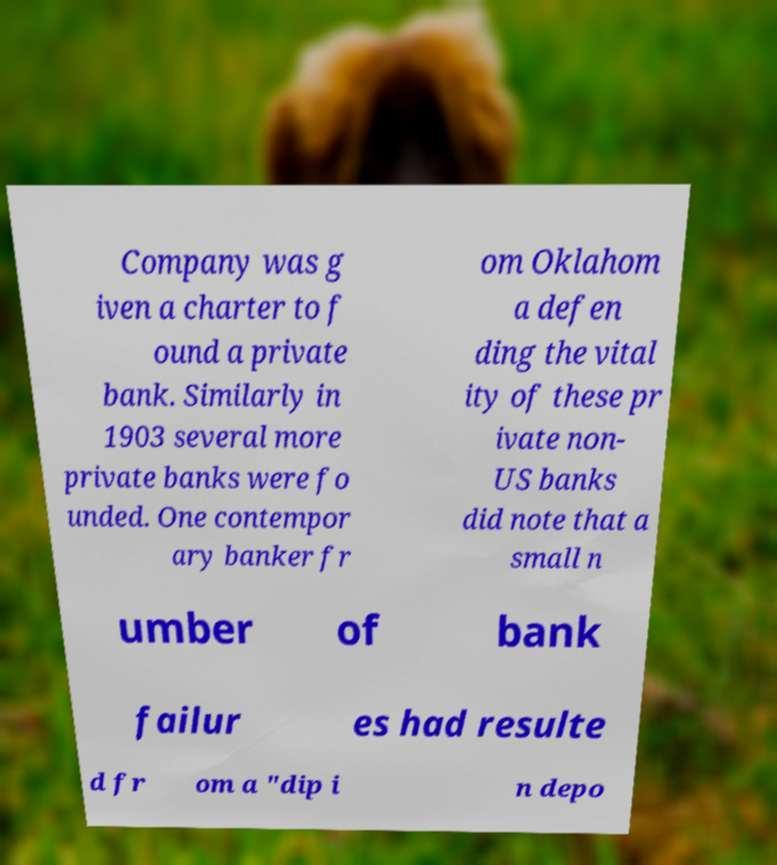Could you extract and type out the text from this image? Company was g iven a charter to f ound a private bank. Similarly in 1903 several more private banks were fo unded. One contempor ary banker fr om Oklahom a defen ding the vital ity of these pr ivate non- US banks did note that a small n umber of bank failur es had resulte d fr om a "dip i n depo 